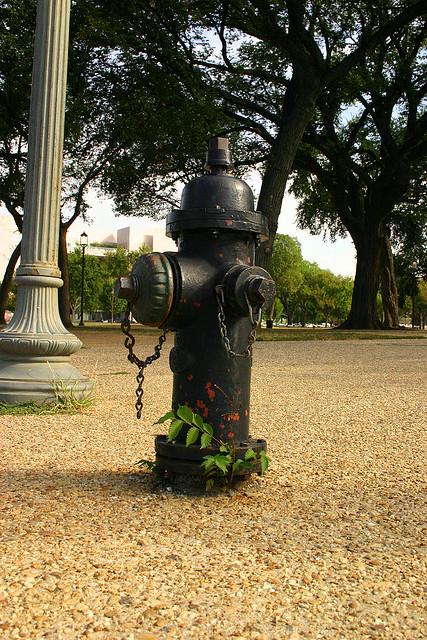What can be seen beyond the trees?
Write a very short answer. Buildings. Is it wintertime?
Answer briefly. No. What does the black thing do?
Short answer required. Fire hydrant. 